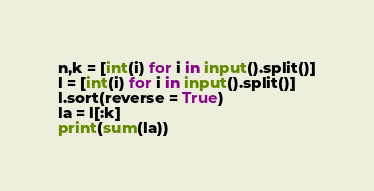Convert code to text. <code><loc_0><loc_0><loc_500><loc_500><_Python_>n,k = [int(i) for i in input().split()]
l = [int(i) for i in input().split()]
l.sort(reverse = True)
la = l[:k]
print(sum(la))</code> 